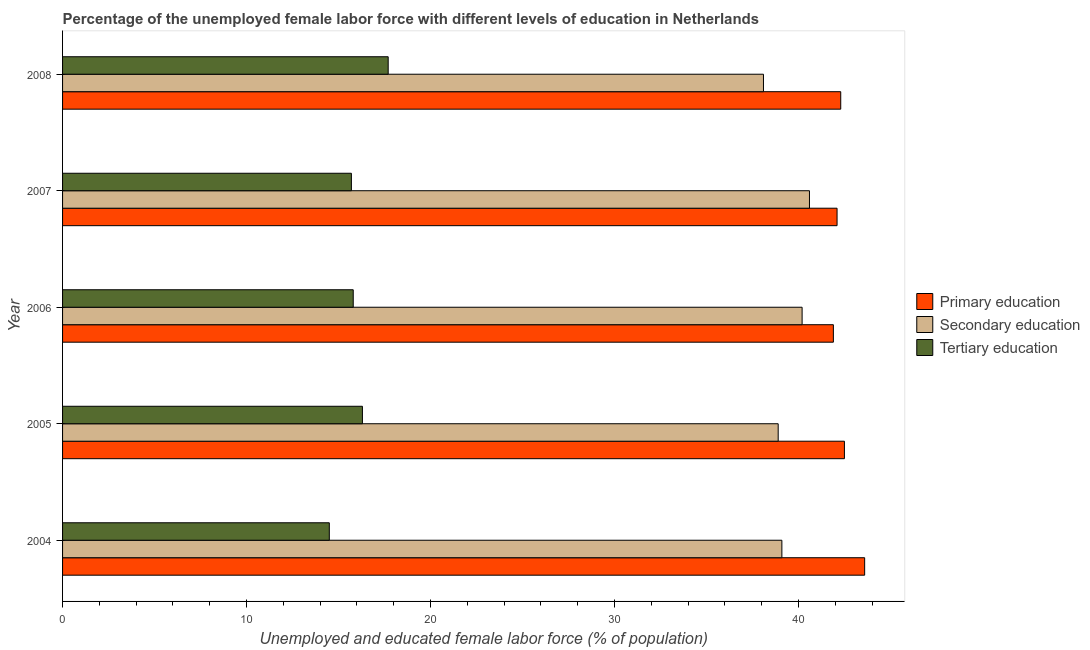Are the number of bars per tick equal to the number of legend labels?
Keep it short and to the point. Yes. Are the number of bars on each tick of the Y-axis equal?
Offer a terse response. Yes. How many bars are there on the 4th tick from the bottom?
Your answer should be very brief. 3. What is the label of the 4th group of bars from the top?
Your answer should be very brief. 2005. What is the percentage of female labor force who received secondary education in 2006?
Provide a succinct answer. 40.2. Across all years, what is the maximum percentage of female labor force who received tertiary education?
Offer a terse response. 17.7. Across all years, what is the minimum percentage of female labor force who received secondary education?
Offer a terse response. 38.1. What is the total percentage of female labor force who received primary education in the graph?
Offer a terse response. 212.4. What is the difference between the percentage of female labor force who received tertiary education in 2005 and that in 2008?
Give a very brief answer. -1.4. What is the difference between the percentage of female labor force who received tertiary education in 2007 and the percentage of female labor force who received primary education in 2005?
Make the answer very short. -26.8. What is the average percentage of female labor force who received tertiary education per year?
Make the answer very short. 16. Is the percentage of female labor force who received primary education in 2005 less than that in 2008?
Your answer should be very brief. No. Is the difference between the percentage of female labor force who received secondary education in 2004 and 2005 greater than the difference between the percentage of female labor force who received tertiary education in 2004 and 2005?
Ensure brevity in your answer.  Yes. What is the difference between the highest and the second highest percentage of female labor force who received secondary education?
Make the answer very short. 0.4. What is the difference between the highest and the lowest percentage of female labor force who received tertiary education?
Your answer should be compact. 3.2. What does the 3rd bar from the top in 2007 represents?
Give a very brief answer. Primary education. What does the 3rd bar from the bottom in 2007 represents?
Your answer should be very brief. Tertiary education. Are all the bars in the graph horizontal?
Give a very brief answer. Yes. How many years are there in the graph?
Provide a short and direct response. 5. What is the difference between two consecutive major ticks on the X-axis?
Your response must be concise. 10. Are the values on the major ticks of X-axis written in scientific E-notation?
Your answer should be compact. No. Does the graph contain any zero values?
Offer a terse response. No. How are the legend labels stacked?
Make the answer very short. Vertical. What is the title of the graph?
Provide a short and direct response. Percentage of the unemployed female labor force with different levels of education in Netherlands. What is the label or title of the X-axis?
Your answer should be very brief. Unemployed and educated female labor force (% of population). What is the label or title of the Y-axis?
Make the answer very short. Year. What is the Unemployed and educated female labor force (% of population) of Primary education in 2004?
Provide a short and direct response. 43.6. What is the Unemployed and educated female labor force (% of population) of Secondary education in 2004?
Your answer should be compact. 39.1. What is the Unemployed and educated female labor force (% of population) of Primary education in 2005?
Ensure brevity in your answer.  42.5. What is the Unemployed and educated female labor force (% of population) in Secondary education in 2005?
Ensure brevity in your answer.  38.9. What is the Unemployed and educated female labor force (% of population) in Tertiary education in 2005?
Provide a short and direct response. 16.3. What is the Unemployed and educated female labor force (% of population) of Primary education in 2006?
Provide a short and direct response. 41.9. What is the Unemployed and educated female labor force (% of population) in Secondary education in 2006?
Your response must be concise. 40.2. What is the Unemployed and educated female labor force (% of population) of Tertiary education in 2006?
Offer a very short reply. 15.8. What is the Unemployed and educated female labor force (% of population) of Primary education in 2007?
Your response must be concise. 42.1. What is the Unemployed and educated female labor force (% of population) of Secondary education in 2007?
Your response must be concise. 40.6. What is the Unemployed and educated female labor force (% of population) of Tertiary education in 2007?
Give a very brief answer. 15.7. What is the Unemployed and educated female labor force (% of population) in Primary education in 2008?
Provide a succinct answer. 42.3. What is the Unemployed and educated female labor force (% of population) of Secondary education in 2008?
Offer a terse response. 38.1. What is the Unemployed and educated female labor force (% of population) in Tertiary education in 2008?
Offer a very short reply. 17.7. Across all years, what is the maximum Unemployed and educated female labor force (% of population) in Primary education?
Provide a short and direct response. 43.6. Across all years, what is the maximum Unemployed and educated female labor force (% of population) of Secondary education?
Keep it short and to the point. 40.6. Across all years, what is the maximum Unemployed and educated female labor force (% of population) in Tertiary education?
Provide a short and direct response. 17.7. Across all years, what is the minimum Unemployed and educated female labor force (% of population) of Primary education?
Provide a short and direct response. 41.9. Across all years, what is the minimum Unemployed and educated female labor force (% of population) in Secondary education?
Your answer should be very brief. 38.1. What is the total Unemployed and educated female labor force (% of population) of Primary education in the graph?
Give a very brief answer. 212.4. What is the total Unemployed and educated female labor force (% of population) of Secondary education in the graph?
Ensure brevity in your answer.  196.9. What is the total Unemployed and educated female labor force (% of population) of Tertiary education in the graph?
Your answer should be very brief. 80. What is the difference between the Unemployed and educated female labor force (% of population) in Secondary education in 2004 and that in 2005?
Your response must be concise. 0.2. What is the difference between the Unemployed and educated female labor force (% of population) of Tertiary education in 2004 and that in 2005?
Offer a very short reply. -1.8. What is the difference between the Unemployed and educated female labor force (% of population) in Secondary education in 2004 and that in 2006?
Give a very brief answer. -1.1. What is the difference between the Unemployed and educated female labor force (% of population) of Primary education in 2004 and that in 2007?
Offer a terse response. 1.5. What is the difference between the Unemployed and educated female labor force (% of population) of Secondary education in 2004 and that in 2007?
Give a very brief answer. -1.5. What is the difference between the Unemployed and educated female labor force (% of population) in Secondary education in 2004 and that in 2008?
Provide a succinct answer. 1. What is the difference between the Unemployed and educated female labor force (% of population) in Tertiary education in 2004 and that in 2008?
Make the answer very short. -3.2. What is the difference between the Unemployed and educated female labor force (% of population) of Primary education in 2005 and that in 2006?
Your answer should be compact. 0.6. What is the difference between the Unemployed and educated female labor force (% of population) of Secondary education in 2005 and that in 2007?
Offer a terse response. -1.7. What is the difference between the Unemployed and educated female labor force (% of population) of Tertiary education in 2005 and that in 2007?
Give a very brief answer. 0.6. What is the difference between the Unemployed and educated female labor force (% of population) in Primary education in 2005 and that in 2008?
Your answer should be very brief. 0.2. What is the difference between the Unemployed and educated female labor force (% of population) of Secondary education in 2005 and that in 2008?
Your answer should be compact. 0.8. What is the difference between the Unemployed and educated female labor force (% of population) of Primary education in 2006 and that in 2007?
Ensure brevity in your answer.  -0.2. What is the difference between the Unemployed and educated female labor force (% of population) in Secondary education in 2006 and that in 2007?
Keep it short and to the point. -0.4. What is the difference between the Unemployed and educated female labor force (% of population) in Secondary education in 2006 and that in 2008?
Keep it short and to the point. 2.1. What is the difference between the Unemployed and educated female labor force (% of population) in Tertiary education in 2006 and that in 2008?
Keep it short and to the point. -1.9. What is the difference between the Unemployed and educated female labor force (% of population) of Secondary education in 2007 and that in 2008?
Offer a terse response. 2.5. What is the difference between the Unemployed and educated female labor force (% of population) in Primary education in 2004 and the Unemployed and educated female labor force (% of population) in Tertiary education in 2005?
Your answer should be compact. 27.3. What is the difference between the Unemployed and educated female labor force (% of population) of Secondary education in 2004 and the Unemployed and educated female labor force (% of population) of Tertiary education in 2005?
Your answer should be compact. 22.8. What is the difference between the Unemployed and educated female labor force (% of population) in Primary education in 2004 and the Unemployed and educated female labor force (% of population) in Tertiary education in 2006?
Provide a succinct answer. 27.8. What is the difference between the Unemployed and educated female labor force (% of population) in Secondary education in 2004 and the Unemployed and educated female labor force (% of population) in Tertiary education in 2006?
Ensure brevity in your answer.  23.3. What is the difference between the Unemployed and educated female labor force (% of population) of Primary education in 2004 and the Unemployed and educated female labor force (% of population) of Secondary education in 2007?
Give a very brief answer. 3. What is the difference between the Unemployed and educated female labor force (% of population) in Primary education in 2004 and the Unemployed and educated female labor force (% of population) in Tertiary education in 2007?
Offer a terse response. 27.9. What is the difference between the Unemployed and educated female labor force (% of population) of Secondary education in 2004 and the Unemployed and educated female labor force (% of population) of Tertiary education in 2007?
Ensure brevity in your answer.  23.4. What is the difference between the Unemployed and educated female labor force (% of population) of Primary education in 2004 and the Unemployed and educated female labor force (% of population) of Tertiary education in 2008?
Offer a very short reply. 25.9. What is the difference between the Unemployed and educated female labor force (% of population) in Secondary education in 2004 and the Unemployed and educated female labor force (% of population) in Tertiary education in 2008?
Your answer should be very brief. 21.4. What is the difference between the Unemployed and educated female labor force (% of population) in Primary education in 2005 and the Unemployed and educated female labor force (% of population) in Tertiary education in 2006?
Make the answer very short. 26.7. What is the difference between the Unemployed and educated female labor force (% of population) in Secondary education in 2005 and the Unemployed and educated female labor force (% of population) in Tertiary education in 2006?
Keep it short and to the point. 23.1. What is the difference between the Unemployed and educated female labor force (% of population) of Primary education in 2005 and the Unemployed and educated female labor force (% of population) of Secondary education in 2007?
Your answer should be very brief. 1.9. What is the difference between the Unemployed and educated female labor force (% of population) in Primary education in 2005 and the Unemployed and educated female labor force (% of population) in Tertiary education in 2007?
Make the answer very short. 26.8. What is the difference between the Unemployed and educated female labor force (% of population) in Secondary education in 2005 and the Unemployed and educated female labor force (% of population) in Tertiary education in 2007?
Ensure brevity in your answer.  23.2. What is the difference between the Unemployed and educated female labor force (% of population) in Primary education in 2005 and the Unemployed and educated female labor force (% of population) in Secondary education in 2008?
Your answer should be compact. 4.4. What is the difference between the Unemployed and educated female labor force (% of population) of Primary education in 2005 and the Unemployed and educated female labor force (% of population) of Tertiary education in 2008?
Give a very brief answer. 24.8. What is the difference between the Unemployed and educated female labor force (% of population) of Secondary education in 2005 and the Unemployed and educated female labor force (% of population) of Tertiary education in 2008?
Your answer should be very brief. 21.2. What is the difference between the Unemployed and educated female labor force (% of population) of Primary education in 2006 and the Unemployed and educated female labor force (% of population) of Tertiary education in 2007?
Your response must be concise. 26.2. What is the difference between the Unemployed and educated female labor force (% of population) of Primary education in 2006 and the Unemployed and educated female labor force (% of population) of Secondary education in 2008?
Make the answer very short. 3.8. What is the difference between the Unemployed and educated female labor force (% of population) of Primary education in 2006 and the Unemployed and educated female labor force (% of population) of Tertiary education in 2008?
Your answer should be compact. 24.2. What is the difference between the Unemployed and educated female labor force (% of population) in Primary education in 2007 and the Unemployed and educated female labor force (% of population) in Secondary education in 2008?
Make the answer very short. 4. What is the difference between the Unemployed and educated female labor force (% of population) in Primary education in 2007 and the Unemployed and educated female labor force (% of population) in Tertiary education in 2008?
Offer a terse response. 24.4. What is the difference between the Unemployed and educated female labor force (% of population) of Secondary education in 2007 and the Unemployed and educated female labor force (% of population) of Tertiary education in 2008?
Ensure brevity in your answer.  22.9. What is the average Unemployed and educated female labor force (% of population) of Primary education per year?
Give a very brief answer. 42.48. What is the average Unemployed and educated female labor force (% of population) in Secondary education per year?
Make the answer very short. 39.38. What is the average Unemployed and educated female labor force (% of population) in Tertiary education per year?
Offer a very short reply. 16. In the year 2004, what is the difference between the Unemployed and educated female labor force (% of population) in Primary education and Unemployed and educated female labor force (% of population) in Tertiary education?
Keep it short and to the point. 29.1. In the year 2004, what is the difference between the Unemployed and educated female labor force (% of population) of Secondary education and Unemployed and educated female labor force (% of population) of Tertiary education?
Your response must be concise. 24.6. In the year 2005, what is the difference between the Unemployed and educated female labor force (% of population) in Primary education and Unemployed and educated female labor force (% of population) in Secondary education?
Your answer should be very brief. 3.6. In the year 2005, what is the difference between the Unemployed and educated female labor force (% of population) in Primary education and Unemployed and educated female labor force (% of population) in Tertiary education?
Give a very brief answer. 26.2. In the year 2005, what is the difference between the Unemployed and educated female labor force (% of population) of Secondary education and Unemployed and educated female labor force (% of population) of Tertiary education?
Offer a very short reply. 22.6. In the year 2006, what is the difference between the Unemployed and educated female labor force (% of population) of Primary education and Unemployed and educated female labor force (% of population) of Secondary education?
Offer a very short reply. 1.7. In the year 2006, what is the difference between the Unemployed and educated female labor force (% of population) of Primary education and Unemployed and educated female labor force (% of population) of Tertiary education?
Your response must be concise. 26.1. In the year 2006, what is the difference between the Unemployed and educated female labor force (% of population) in Secondary education and Unemployed and educated female labor force (% of population) in Tertiary education?
Make the answer very short. 24.4. In the year 2007, what is the difference between the Unemployed and educated female labor force (% of population) in Primary education and Unemployed and educated female labor force (% of population) in Secondary education?
Offer a terse response. 1.5. In the year 2007, what is the difference between the Unemployed and educated female labor force (% of population) of Primary education and Unemployed and educated female labor force (% of population) of Tertiary education?
Provide a succinct answer. 26.4. In the year 2007, what is the difference between the Unemployed and educated female labor force (% of population) in Secondary education and Unemployed and educated female labor force (% of population) in Tertiary education?
Offer a terse response. 24.9. In the year 2008, what is the difference between the Unemployed and educated female labor force (% of population) of Primary education and Unemployed and educated female labor force (% of population) of Tertiary education?
Provide a short and direct response. 24.6. In the year 2008, what is the difference between the Unemployed and educated female labor force (% of population) of Secondary education and Unemployed and educated female labor force (% of population) of Tertiary education?
Ensure brevity in your answer.  20.4. What is the ratio of the Unemployed and educated female labor force (% of population) in Primary education in 2004 to that in 2005?
Provide a succinct answer. 1.03. What is the ratio of the Unemployed and educated female labor force (% of population) of Secondary education in 2004 to that in 2005?
Keep it short and to the point. 1.01. What is the ratio of the Unemployed and educated female labor force (% of population) of Tertiary education in 2004 to that in 2005?
Make the answer very short. 0.89. What is the ratio of the Unemployed and educated female labor force (% of population) in Primary education in 2004 to that in 2006?
Ensure brevity in your answer.  1.04. What is the ratio of the Unemployed and educated female labor force (% of population) in Secondary education in 2004 to that in 2006?
Provide a short and direct response. 0.97. What is the ratio of the Unemployed and educated female labor force (% of population) in Tertiary education in 2004 to that in 2006?
Ensure brevity in your answer.  0.92. What is the ratio of the Unemployed and educated female labor force (% of population) of Primary education in 2004 to that in 2007?
Your answer should be compact. 1.04. What is the ratio of the Unemployed and educated female labor force (% of population) of Secondary education in 2004 to that in 2007?
Your answer should be very brief. 0.96. What is the ratio of the Unemployed and educated female labor force (% of population) in Tertiary education in 2004 to that in 2007?
Ensure brevity in your answer.  0.92. What is the ratio of the Unemployed and educated female labor force (% of population) in Primary education in 2004 to that in 2008?
Give a very brief answer. 1.03. What is the ratio of the Unemployed and educated female labor force (% of population) in Secondary education in 2004 to that in 2008?
Your answer should be compact. 1.03. What is the ratio of the Unemployed and educated female labor force (% of population) of Tertiary education in 2004 to that in 2008?
Your answer should be very brief. 0.82. What is the ratio of the Unemployed and educated female labor force (% of population) of Primary education in 2005 to that in 2006?
Provide a succinct answer. 1.01. What is the ratio of the Unemployed and educated female labor force (% of population) in Secondary education in 2005 to that in 2006?
Your answer should be compact. 0.97. What is the ratio of the Unemployed and educated female labor force (% of population) of Tertiary education in 2005 to that in 2006?
Your response must be concise. 1.03. What is the ratio of the Unemployed and educated female labor force (% of population) of Primary education in 2005 to that in 2007?
Make the answer very short. 1.01. What is the ratio of the Unemployed and educated female labor force (% of population) in Secondary education in 2005 to that in 2007?
Provide a short and direct response. 0.96. What is the ratio of the Unemployed and educated female labor force (% of population) of Tertiary education in 2005 to that in 2007?
Make the answer very short. 1.04. What is the ratio of the Unemployed and educated female labor force (% of population) of Primary education in 2005 to that in 2008?
Your answer should be compact. 1. What is the ratio of the Unemployed and educated female labor force (% of population) in Tertiary education in 2005 to that in 2008?
Your response must be concise. 0.92. What is the ratio of the Unemployed and educated female labor force (% of population) in Tertiary education in 2006 to that in 2007?
Provide a succinct answer. 1.01. What is the ratio of the Unemployed and educated female labor force (% of population) of Primary education in 2006 to that in 2008?
Provide a succinct answer. 0.99. What is the ratio of the Unemployed and educated female labor force (% of population) in Secondary education in 2006 to that in 2008?
Your answer should be very brief. 1.06. What is the ratio of the Unemployed and educated female labor force (% of population) in Tertiary education in 2006 to that in 2008?
Offer a very short reply. 0.89. What is the ratio of the Unemployed and educated female labor force (% of population) in Secondary education in 2007 to that in 2008?
Keep it short and to the point. 1.07. What is the ratio of the Unemployed and educated female labor force (% of population) of Tertiary education in 2007 to that in 2008?
Give a very brief answer. 0.89. What is the difference between the highest and the second highest Unemployed and educated female labor force (% of population) in Secondary education?
Your answer should be compact. 0.4. What is the difference between the highest and the second highest Unemployed and educated female labor force (% of population) of Tertiary education?
Your answer should be very brief. 1.4. What is the difference between the highest and the lowest Unemployed and educated female labor force (% of population) in Secondary education?
Provide a succinct answer. 2.5. 